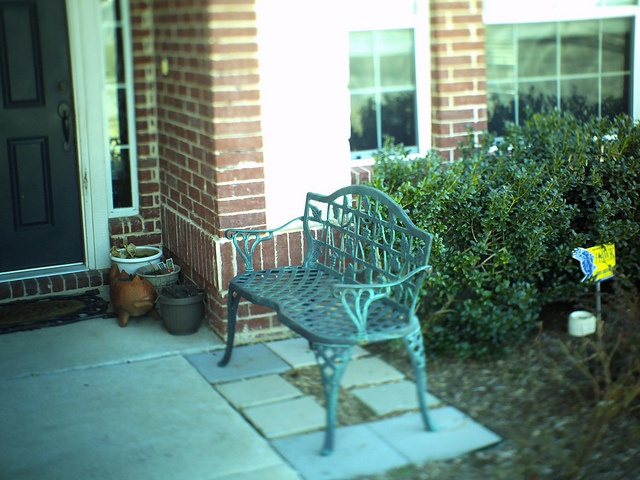Describe the objects in this image and their specific colors. I can see bench in black, teal, and turquoise tones, potted plant in black and teal tones, potted plant in black, teal, and lightblue tones, and potted plant in black and teal tones in this image. 